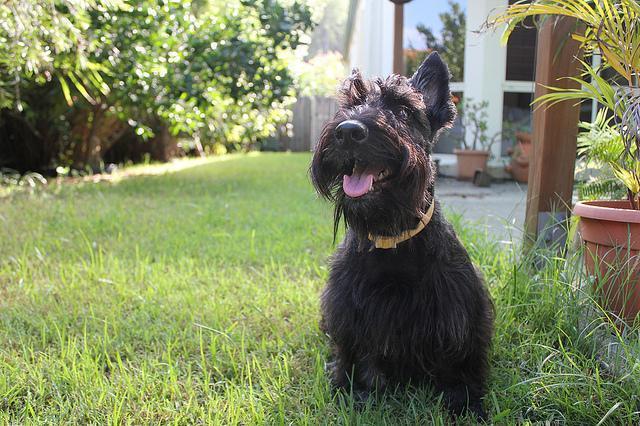How many dogs are there?
Give a very brief answer. 1. How many potted plants are there?
Give a very brief answer. 2. How many hands does the gold-rimmed clock have?
Give a very brief answer. 0. 